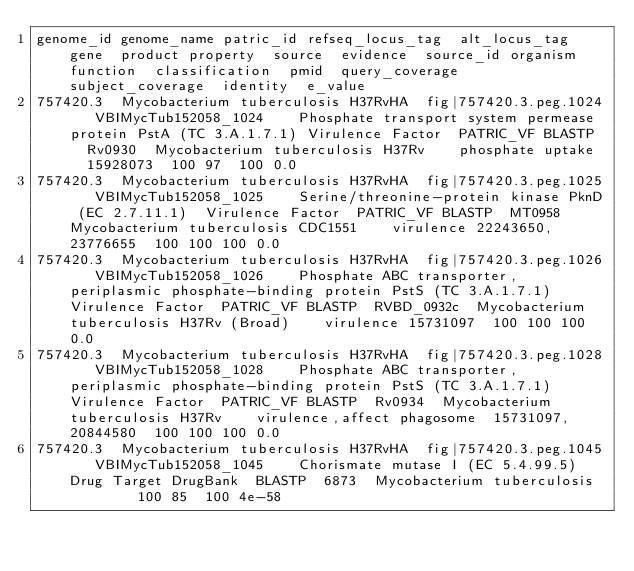<code> <loc_0><loc_0><loc_500><loc_500><_SQL_>genome_id	genome_name	patric_id	refseq_locus_tag	alt_locus_tag	gene	product	property	source	evidence	source_id	organism	function	classification	pmid	query_coverage	subject_coverage	identity	e_value
757420.3	Mycobacterium tuberculosis H37RvHA	fig|757420.3.peg.1024		VBIMycTub152058_1024		Phosphate transport system permease protein PstA (TC 3.A.1.7.1)	Virulence Factor	PATRIC_VF	BLASTP	Rv0930	Mycobacterium tuberculosis H37Rv		phosphate uptake	15928073	100	97	100	0.0
757420.3	Mycobacterium tuberculosis H37RvHA	fig|757420.3.peg.1025		VBIMycTub152058_1025		Serine/threonine-protein kinase PknD (EC 2.7.11.1)	Virulence Factor	PATRIC_VF	BLASTP	MT0958	Mycobacterium tuberculosis CDC1551		virulence	22243650, 23776655	100	100	100	0.0
757420.3	Mycobacterium tuberculosis H37RvHA	fig|757420.3.peg.1026		VBIMycTub152058_1026		Phosphate ABC transporter, periplasmic phosphate-binding protein PstS (TC 3.A.1.7.1)	Virulence Factor	PATRIC_VF	BLASTP	RVBD_0932c	Mycobacterium tuberculosis H37Rv (Broad)		virulence	15731097	100	100	100	0.0
757420.3	Mycobacterium tuberculosis H37RvHA	fig|757420.3.peg.1028		VBIMycTub152058_1028		Phosphate ABC transporter, periplasmic phosphate-binding protein PstS (TC 3.A.1.7.1)	Virulence Factor	PATRIC_VF	BLASTP	Rv0934	Mycobacterium tuberculosis H37Rv		virulence,affect phagosome	15731097, 20844580	100	100	100	0.0
757420.3	Mycobacterium tuberculosis H37RvHA	fig|757420.3.peg.1045		VBIMycTub152058_1045		Chorismate mutase I (EC 5.4.99.5)	Drug Target	DrugBank	BLASTP	6873	Mycobacterium tuberculosis				100	85	100	4e-58</code> 